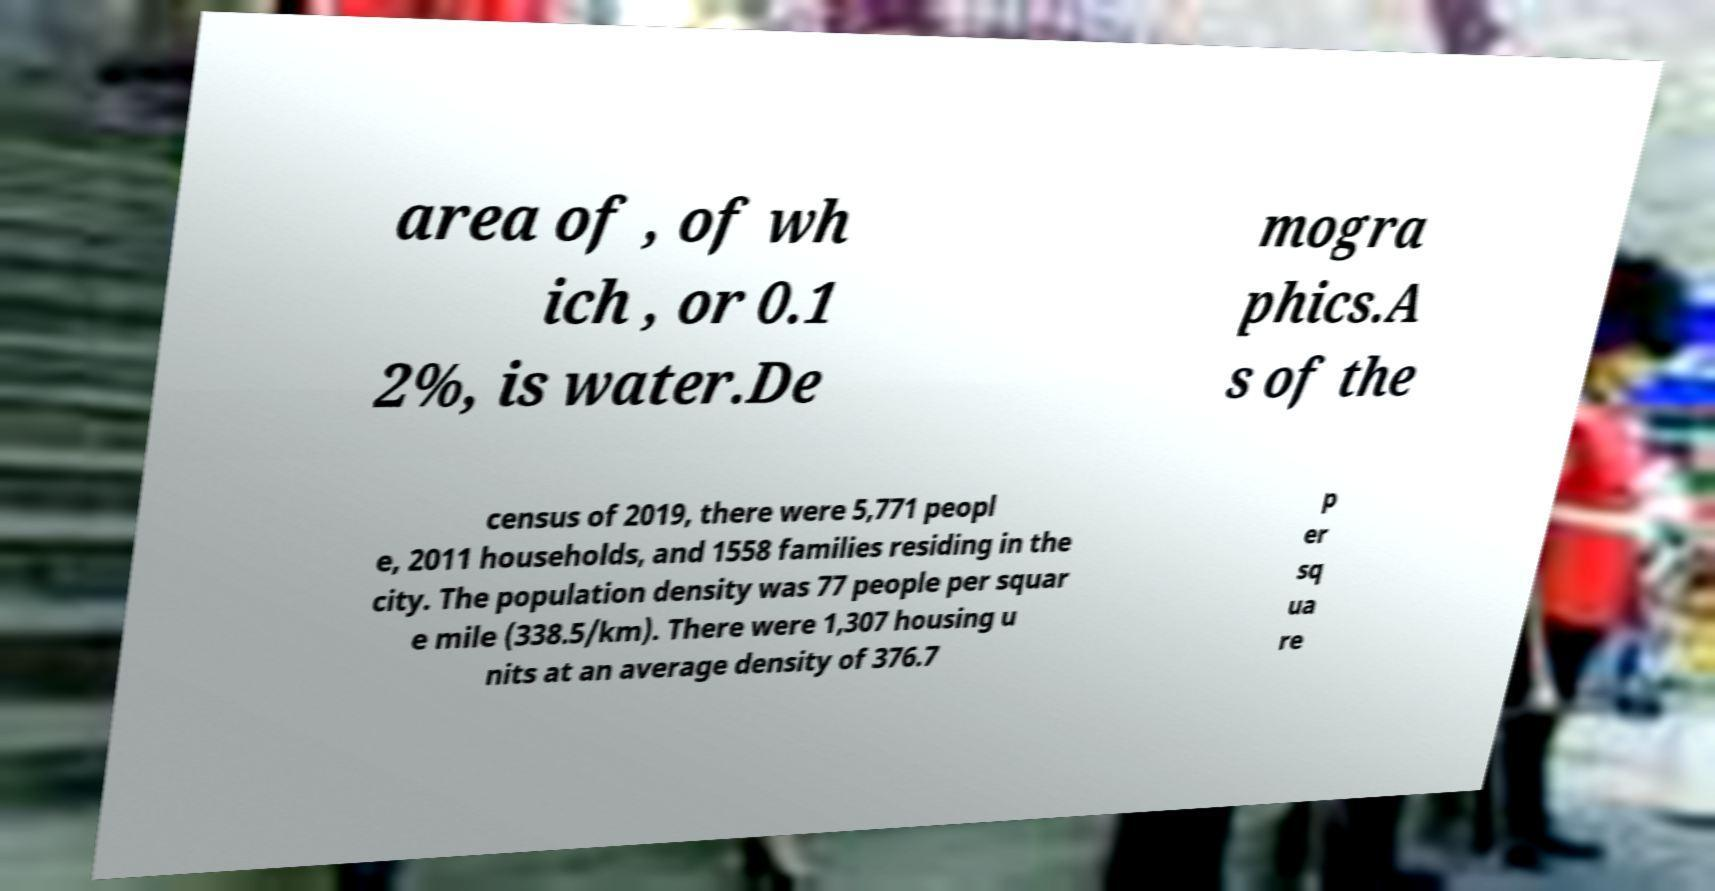For documentation purposes, I need the text within this image transcribed. Could you provide that? area of , of wh ich , or 0.1 2%, is water.De mogra phics.A s of the census of 2019, there were 5,771 peopl e, 2011 households, and 1558 families residing in the city. The population density was 77 people per squar e mile (338.5/km). There were 1,307 housing u nits at an average density of 376.7 p er sq ua re 